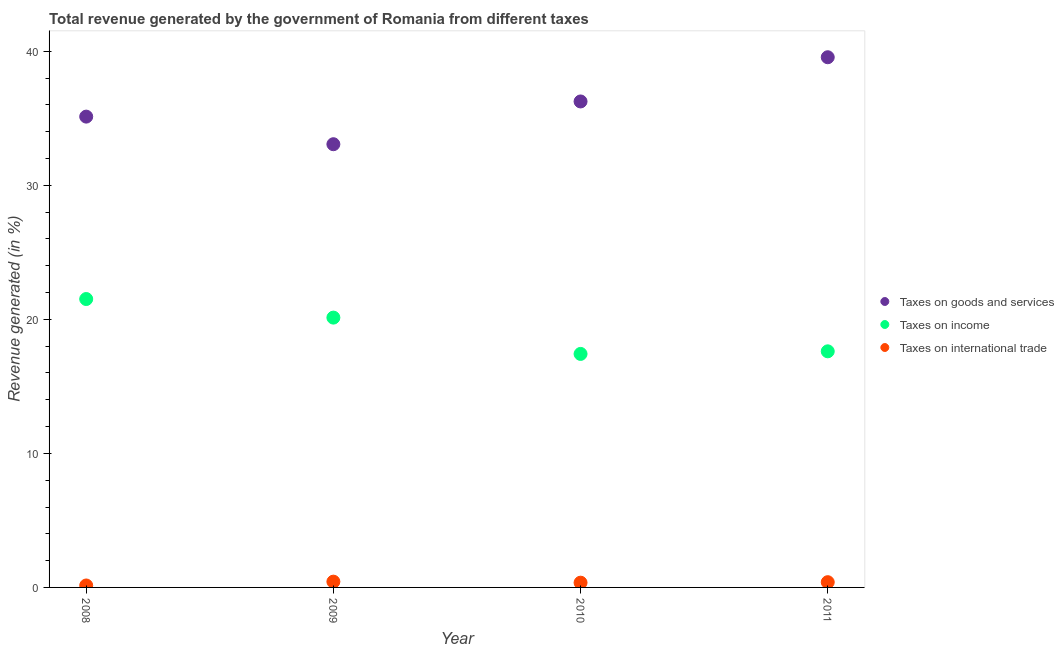How many different coloured dotlines are there?
Ensure brevity in your answer.  3. Is the number of dotlines equal to the number of legend labels?
Your answer should be very brief. Yes. What is the percentage of revenue generated by taxes on income in 2011?
Provide a short and direct response. 17.62. Across all years, what is the maximum percentage of revenue generated by tax on international trade?
Your response must be concise. 0.43. Across all years, what is the minimum percentage of revenue generated by taxes on income?
Keep it short and to the point. 17.42. In which year was the percentage of revenue generated by tax on international trade minimum?
Give a very brief answer. 2008. What is the total percentage of revenue generated by tax on international trade in the graph?
Offer a very short reply. 1.32. What is the difference between the percentage of revenue generated by tax on international trade in 2009 and that in 2010?
Give a very brief answer. 0.08. What is the difference between the percentage of revenue generated by taxes on goods and services in 2009 and the percentage of revenue generated by tax on international trade in 2008?
Offer a terse response. 32.92. What is the average percentage of revenue generated by taxes on income per year?
Your answer should be compact. 19.17. In the year 2010, what is the difference between the percentage of revenue generated by taxes on income and percentage of revenue generated by taxes on goods and services?
Give a very brief answer. -18.84. In how many years, is the percentage of revenue generated by taxes on goods and services greater than 32 %?
Provide a short and direct response. 4. What is the ratio of the percentage of revenue generated by taxes on goods and services in 2008 to that in 2011?
Your answer should be compact. 0.89. Is the difference between the percentage of revenue generated by tax on international trade in 2009 and 2010 greater than the difference between the percentage of revenue generated by taxes on goods and services in 2009 and 2010?
Keep it short and to the point. Yes. What is the difference between the highest and the second highest percentage of revenue generated by taxes on goods and services?
Provide a short and direct response. 3.3. What is the difference between the highest and the lowest percentage of revenue generated by taxes on goods and services?
Give a very brief answer. 6.49. Is the sum of the percentage of revenue generated by taxes on goods and services in 2009 and 2011 greater than the maximum percentage of revenue generated by taxes on income across all years?
Provide a succinct answer. Yes. Is it the case that in every year, the sum of the percentage of revenue generated by taxes on goods and services and percentage of revenue generated by taxes on income is greater than the percentage of revenue generated by tax on international trade?
Offer a terse response. Yes. Does the percentage of revenue generated by taxes on goods and services monotonically increase over the years?
Ensure brevity in your answer.  No. Is the percentage of revenue generated by tax on international trade strictly less than the percentage of revenue generated by taxes on goods and services over the years?
Offer a very short reply. Yes. How many years are there in the graph?
Make the answer very short. 4. Are the values on the major ticks of Y-axis written in scientific E-notation?
Your answer should be compact. No. Does the graph contain grids?
Make the answer very short. No. Where does the legend appear in the graph?
Make the answer very short. Center right. How many legend labels are there?
Make the answer very short. 3. What is the title of the graph?
Make the answer very short. Total revenue generated by the government of Romania from different taxes. Does "Ages 65 and above" appear as one of the legend labels in the graph?
Offer a very short reply. No. What is the label or title of the Y-axis?
Ensure brevity in your answer.  Revenue generated (in %). What is the Revenue generated (in %) in Taxes on goods and services in 2008?
Give a very brief answer. 35.13. What is the Revenue generated (in %) in Taxes on income in 2008?
Offer a very short reply. 21.52. What is the Revenue generated (in %) of Taxes on international trade in 2008?
Your answer should be very brief. 0.14. What is the Revenue generated (in %) of Taxes on goods and services in 2009?
Ensure brevity in your answer.  33.07. What is the Revenue generated (in %) in Taxes on income in 2009?
Ensure brevity in your answer.  20.13. What is the Revenue generated (in %) in Taxes on international trade in 2009?
Give a very brief answer. 0.43. What is the Revenue generated (in %) of Taxes on goods and services in 2010?
Make the answer very short. 36.26. What is the Revenue generated (in %) in Taxes on income in 2010?
Your answer should be very brief. 17.42. What is the Revenue generated (in %) in Taxes on international trade in 2010?
Ensure brevity in your answer.  0.35. What is the Revenue generated (in %) of Taxes on goods and services in 2011?
Your answer should be compact. 39.56. What is the Revenue generated (in %) of Taxes on income in 2011?
Your answer should be compact. 17.62. What is the Revenue generated (in %) of Taxes on international trade in 2011?
Provide a succinct answer. 0.39. Across all years, what is the maximum Revenue generated (in %) in Taxes on goods and services?
Keep it short and to the point. 39.56. Across all years, what is the maximum Revenue generated (in %) of Taxes on income?
Keep it short and to the point. 21.52. Across all years, what is the maximum Revenue generated (in %) in Taxes on international trade?
Keep it short and to the point. 0.43. Across all years, what is the minimum Revenue generated (in %) of Taxes on goods and services?
Provide a succinct answer. 33.07. Across all years, what is the minimum Revenue generated (in %) in Taxes on income?
Give a very brief answer. 17.42. Across all years, what is the minimum Revenue generated (in %) in Taxes on international trade?
Ensure brevity in your answer.  0.14. What is the total Revenue generated (in %) in Taxes on goods and services in the graph?
Make the answer very short. 144.01. What is the total Revenue generated (in %) of Taxes on income in the graph?
Ensure brevity in your answer.  76.68. What is the total Revenue generated (in %) of Taxes on international trade in the graph?
Provide a succinct answer. 1.32. What is the difference between the Revenue generated (in %) of Taxes on goods and services in 2008 and that in 2009?
Give a very brief answer. 2.06. What is the difference between the Revenue generated (in %) in Taxes on income in 2008 and that in 2009?
Make the answer very short. 1.39. What is the difference between the Revenue generated (in %) of Taxes on international trade in 2008 and that in 2009?
Provide a succinct answer. -0.29. What is the difference between the Revenue generated (in %) of Taxes on goods and services in 2008 and that in 2010?
Ensure brevity in your answer.  -1.13. What is the difference between the Revenue generated (in %) of Taxes on income in 2008 and that in 2010?
Make the answer very short. 4.1. What is the difference between the Revenue generated (in %) of Taxes on international trade in 2008 and that in 2010?
Your answer should be very brief. -0.21. What is the difference between the Revenue generated (in %) of Taxes on goods and services in 2008 and that in 2011?
Provide a succinct answer. -4.43. What is the difference between the Revenue generated (in %) of Taxes on income in 2008 and that in 2011?
Your answer should be very brief. 3.9. What is the difference between the Revenue generated (in %) in Taxes on international trade in 2008 and that in 2011?
Provide a short and direct response. -0.25. What is the difference between the Revenue generated (in %) of Taxes on goods and services in 2009 and that in 2010?
Keep it short and to the point. -3.19. What is the difference between the Revenue generated (in %) of Taxes on income in 2009 and that in 2010?
Offer a very short reply. 2.71. What is the difference between the Revenue generated (in %) of Taxes on international trade in 2009 and that in 2010?
Keep it short and to the point. 0.08. What is the difference between the Revenue generated (in %) of Taxes on goods and services in 2009 and that in 2011?
Provide a short and direct response. -6.49. What is the difference between the Revenue generated (in %) of Taxes on income in 2009 and that in 2011?
Offer a very short reply. 2.52. What is the difference between the Revenue generated (in %) in Taxes on international trade in 2009 and that in 2011?
Keep it short and to the point. 0.04. What is the difference between the Revenue generated (in %) in Taxes on goods and services in 2010 and that in 2011?
Make the answer very short. -3.3. What is the difference between the Revenue generated (in %) in Taxes on income in 2010 and that in 2011?
Ensure brevity in your answer.  -0.19. What is the difference between the Revenue generated (in %) in Taxes on international trade in 2010 and that in 2011?
Your answer should be compact. -0.04. What is the difference between the Revenue generated (in %) of Taxes on goods and services in 2008 and the Revenue generated (in %) of Taxes on income in 2009?
Your answer should be compact. 15. What is the difference between the Revenue generated (in %) in Taxes on goods and services in 2008 and the Revenue generated (in %) in Taxes on international trade in 2009?
Your response must be concise. 34.7. What is the difference between the Revenue generated (in %) in Taxes on income in 2008 and the Revenue generated (in %) in Taxes on international trade in 2009?
Offer a terse response. 21.09. What is the difference between the Revenue generated (in %) in Taxes on goods and services in 2008 and the Revenue generated (in %) in Taxes on income in 2010?
Offer a terse response. 17.7. What is the difference between the Revenue generated (in %) in Taxes on goods and services in 2008 and the Revenue generated (in %) in Taxes on international trade in 2010?
Make the answer very short. 34.77. What is the difference between the Revenue generated (in %) of Taxes on income in 2008 and the Revenue generated (in %) of Taxes on international trade in 2010?
Offer a very short reply. 21.16. What is the difference between the Revenue generated (in %) in Taxes on goods and services in 2008 and the Revenue generated (in %) in Taxes on income in 2011?
Give a very brief answer. 17.51. What is the difference between the Revenue generated (in %) of Taxes on goods and services in 2008 and the Revenue generated (in %) of Taxes on international trade in 2011?
Give a very brief answer. 34.73. What is the difference between the Revenue generated (in %) in Taxes on income in 2008 and the Revenue generated (in %) in Taxes on international trade in 2011?
Offer a terse response. 21.13. What is the difference between the Revenue generated (in %) in Taxes on goods and services in 2009 and the Revenue generated (in %) in Taxes on income in 2010?
Your answer should be very brief. 15.65. What is the difference between the Revenue generated (in %) of Taxes on goods and services in 2009 and the Revenue generated (in %) of Taxes on international trade in 2010?
Your response must be concise. 32.71. What is the difference between the Revenue generated (in %) of Taxes on income in 2009 and the Revenue generated (in %) of Taxes on international trade in 2010?
Give a very brief answer. 19.78. What is the difference between the Revenue generated (in %) in Taxes on goods and services in 2009 and the Revenue generated (in %) in Taxes on income in 2011?
Give a very brief answer. 15.45. What is the difference between the Revenue generated (in %) in Taxes on goods and services in 2009 and the Revenue generated (in %) in Taxes on international trade in 2011?
Your response must be concise. 32.68. What is the difference between the Revenue generated (in %) in Taxes on income in 2009 and the Revenue generated (in %) in Taxes on international trade in 2011?
Your answer should be very brief. 19.74. What is the difference between the Revenue generated (in %) in Taxes on goods and services in 2010 and the Revenue generated (in %) in Taxes on income in 2011?
Provide a succinct answer. 18.64. What is the difference between the Revenue generated (in %) of Taxes on goods and services in 2010 and the Revenue generated (in %) of Taxes on international trade in 2011?
Provide a short and direct response. 35.87. What is the difference between the Revenue generated (in %) of Taxes on income in 2010 and the Revenue generated (in %) of Taxes on international trade in 2011?
Provide a short and direct response. 17.03. What is the average Revenue generated (in %) in Taxes on goods and services per year?
Your answer should be very brief. 36. What is the average Revenue generated (in %) of Taxes on income per year?
Offer a terse response. 19.17. What is the average Revenue generated (in %) in Taxes on international trade per year?
Provide a short and direct response. 0.33. In the year 2008, what is the difference between the Revenue generated (in %) of Taxes on goods and services and Revenue generated (in %) of Taxes on income?
Provide a short and direct response. 13.61. In the year 2008, what is the difference between the Revenue generated (in %) in Taxes on goods and services and Revenue generated (in %) in Taxes on international trade?
Provide a short and direct response. 34.98. In the year 2008, what is the difference between the Revenue generated (in %) of Taxes on income and Revenue generated (in %) of Taxes on international trade?
Provide a succinct answer. 21.37. In the year 2009, what is the difference between the Revenue generated (in %) in Taxes on goods and services and Revenue generated (in %) in Taxes on income?
Your answer should be very brief. 12.94. In the year 2009, what is the difference between the Revenue generated (in %) of Taxes on goods and services and Revenue generated (in %) of Taxes on international trade?
Ensure brevity in your answer.  32.64. In the year 2009, what is the difference between the Revenue generated (in %) of Taxes on income and Revenue generated (in %) of Taxes on international trade?
Your response must be concise. 19.7. In the year 2010, what is the difference between the Revenue generated (in %) in Taxes on goods and services and Revenue generated (in %) in Taxes on income?
Provide a short and direct response. 18.84. In the year 2010, what is the difference between the Revenue generated (in %) of Taxes on goods and services and Revenue generated (in %) of Taxes on international trade?
Keep it short and to the point. 35.9. In the year 2010, what is the difference between the Revenue generated (in %) of Taxes on income and Revenue generated (in %) of Taxes on international trade?
Keep it short and to the point. 17.07. In the year 2011, what is the difference between the Revenue generated (in %) in Taxes on goods and services and Revenue generated (in %) in Taxes on income?
Keep it short and to the point. 21.94. In the year 2011, what is the difference between the Revenue generated (in %) of Taxes on goods and services and Revenue generated (in %) of Taxes on international trade?
Offer a very short reply. 39.17. In the year 2011, what is the difference between the Revenue generated (in %) in Taxes on income and Revenue generated (in %) in Taxes on international trade?
Make the answer very short. 17.22. What is the ratio of the Revenue generated (in %) in Taxes on goods and services in 2008 to that in 2009?
Ensure brevity in your answer.  1.06. What is the ratio of the Revenue generated (in %) of Taxes on income in 2008 to that in 2009?
Your answer should be compact. 1.07. What is the ratio of the Revenue generated (in %) in Taxes on international trade in 2008 to that in 2009?
Offer a very short reply. 0.34. What is the ratio of the Revenue generated (in %) in Taxes on goods and services in 2008 to that in 2010?
Your answer should be compact. 0.97. What is the ratio of the Revenue generated (in %) of Taxes on income in 2008 to that in 2010?
Offer a terse response. 1.24. What is the ratio of the Revenue generated (in %) of Taxes on international trade in 2008 to that in 2010?
Keep it short and to the point. 0.41. What is the ratio of the Revenue generated (in %) of Taxes on goods and services in 2008 to that in 2011?
Ensure brevity in your answer.  0.89. What is the ratio of the Revenue generated (in %) of Taxes on income in 2008 to that in 2011?
Offer a very short reply. 1.22. What is the ratio of the Revenue generated (in %) of Taxes on international trade in 2008 to that in 2011?
Make the answer very short. 0.37. What is the ratio of the Revenue generated (in %) in Taxes on goods and services in 2009 to that in 2010?
Keep it short and to the point. 0.91. What is the ratio of the Revenue generated (in %) in Taxes on income in 2009 to that in 2010?
Offer a very short reply. 1.16. What is the ratio of the Revenue generated (in %) of Taxes on international trade in 2009 to that in 2010?
Make the answer very short. 1.22. What is the ratio of the Revenue generated (in %) of Taxes on goods and services in 2009 to that in 2011?
Make the answer very short. 0.84. What is the ratio of the Revenue generated (in %) of Taxes on income in 2009 to that in 2011?
Keep it short and to the point. 1.14. What is the ratio of the Revenue generated (in %) of Taxes on international trade in 2009 to that in 2011?
Provide a succinct answer. 1.1. What is the ratio of the Revenue generated (in %) of Taxes on goods and services in 2010 to that in 2011?
Offer a very short reply. 0.92. What is the ratio of the Revenue generated (in %) in Taxes on income in 2010 to that in 2011?
Your answer should be compact. 0.99. What is the ratio of the Revenue generated (in %) of Taxes on international trade in 2010 to that in 2011?
Ensure brevity in your answer.  0.9. What is the difference between the highest and the second highest Revenue generated (in %) of Taxes on goods and services?
Your response must be concise. 3.3. What is the difference between the highest and the second highest Revenue generated (in %) in Taxes on income?
Provide a short and direct response. 1.39. What is the difference between the highest and the second highest Revenue generated (in %) in Taxes on international trade?
Your answer should be compact. 0.04. What is the difference between the highest and the lowest Revenue generated (in %) in Taxes on goods and services?
Keep it short and to the point. 6.49. What is the difference between the highest and the lowest Revenue generated (in %) of Taxes on income?
Offer a terse response. 4.1. What is the difference between the highest and the lowest Revenue generated (in %) in Taxes on international trade?
Your response must be concise. 0.29. 